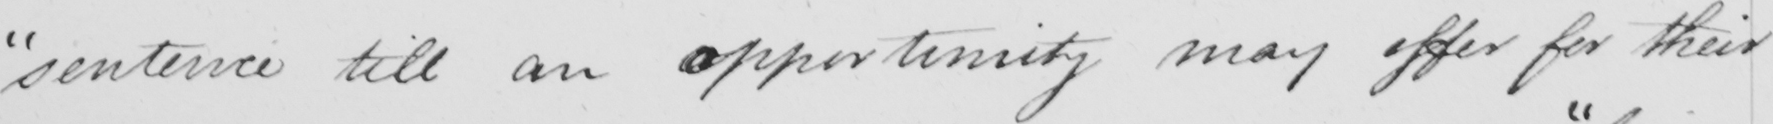Please transcribe the handwritten text in this image. " sentence till an opportunity may offer for their 